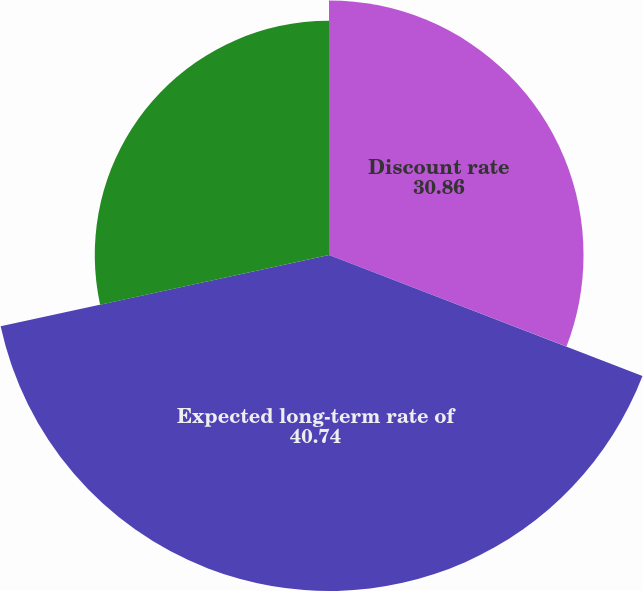Convert chart to OTSL. <chart><loc_0><loc_0><loc_500><loc_500><pie_chart><fcel>Discount rate<fcel>Expected long-term rate of<fcel>Rate of compensation increase<nl><fcel>30.86%<fcel>40.74%<fcel>28.4%<nl></chart> 